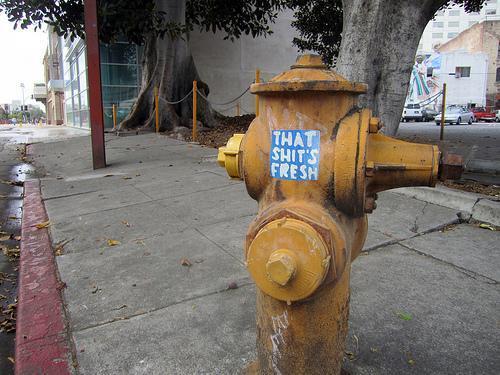How many trees are there?
Give a very brief answer. 2. 